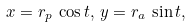Convert formula to latex. <formula><loc_0><loc_0><loc_500><loc_500>x = r _ { p } \, \cos { t } , \, y = r _ { a } \, \sin { t } ,</formula> 